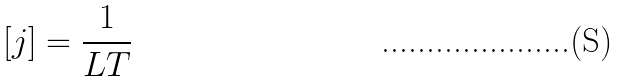Convert formula to latex. <formula><loc_0><loc_0><loc_500><loc_500>\left [ j \right ] = \frac { 1 } { L T }</formula> 